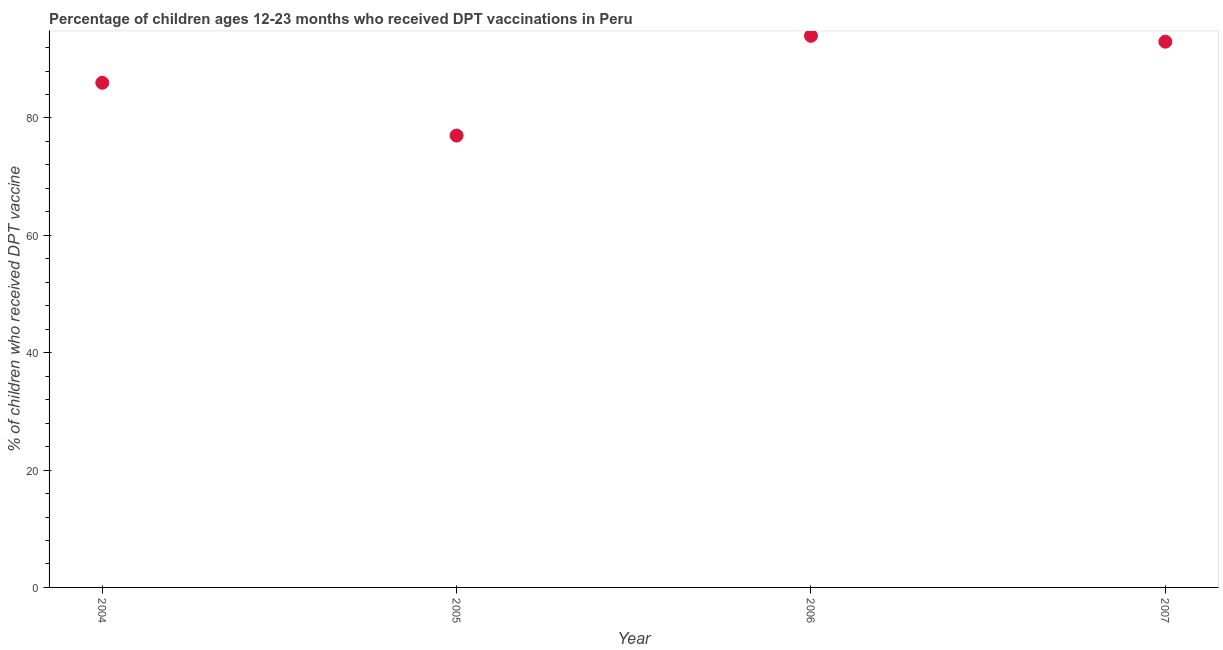What is the percentage of children who received dpt vaccine in 2007?
Offer a very short reply. 93. Across all years, what is the maximum percentage of children who received dpt vaccine?
Your answer should be compact. 94. Across all years, what is the minimum percentage of children who received dpt vaccine?
Your answer should be very brief. 77. In which year was the percentage of children who received dpt vaccine maximum?
Provide a short and direct response. 2006. What is the sum of the percentage of children who received dpt vaccine?
Your answer should be very brief. 350. What is the difference between the percentage of children who received dpt vaccine in 2006 and 2007?
Offer a terse response. 1. What is the average percentage of children who received dpt vaccine per year?
Keep it short and to the point. 87.5. What is the median percentage of children who received dpt vaccine?
Your response must be concise. 89.5. In how many years, is the percentage of children who received dpt vaccine greater than 56 %?
Provide a succinct answer. 4. What is the ratio of the percentage of children who received dpt vaccine in 2005 to that in 2007?
Provide a succinct answer. 0.83. Is the percentage of children who received dpt vaccine in 2004 less than that in 2005?
Provide a short and direct response. No. Is the difference between the percentage of children who received dpt vaccine in 2005 and 2007 greater than the difference between any two years?
Provide a succinct answer. No. Is the sum of the percentage of children who received dpt vaccine in 2004 and 2005 greater than the maximum percentage of children who received dpt vaccine across all years?
Your answer should be compact. Yes. What is the difference between the highest and the lowest percentage of children who received dpt vaccine?
Give a very brief answer. 17. How many dotlines are there?
Provide a short and direct response. 1. What is the title of the graph?
Ensure brevity in your answer.  Percentage of children ages 12-23 months who received DPT vaccinations in Peru. What is the label or title of the Y-axis?
Provide a succinct answer. % of children who received DPT vaccine. What is the % of children who received DPT vaccine in 2006?
Provide a short and direct response. 94. What is the % of children who received DPT vaccine in 2007?
Your answer should be compact. 93. What is the difference between the % of children who received DPT vaccine in 2004 and 2005?
Provide a succinct answer. 9. What is the difference between the % of children who received DPT vaccine in 2004 and 2007?
Provide a short and direct response. -7. What is the difference between the % of children who received DPT vaccine in 2005 and 2006?
Ensure brevity in your answer.  -17. What is the difference between the % of children who received DPT vaccine in 2005 and 2007?
Your answer should be compact. -16. What is the ratio of the % of children who received DPT vaccine in 2004 to that in 2005?
Your response must be concise. 1.12. What is the ratio of the % of children who received DPT vaccine in 2004 to that in 2006?
Give a very brief answer. 0.92. What is the ratio of the % of children who received DPT vaccine in 2004 to that in 2007?
Your response must be concise. 0.93. What is the ratio of the % of children who received DPT vaccine in 2005 to that in 2006?
Provide a short and direct response. 0.82. What is the ratio of the % of children who received DPT vaccine in 2005 to that in 2007?
Your answer should be compact. 0.83. 